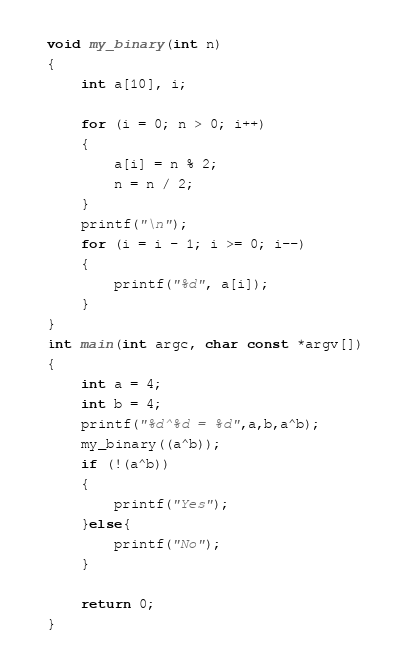Convert code to text. <code><loc_0><loc_0><loc_500><loc_500><_C_>void my_binary(int n)
{
    int a[10], i;

    for (i = 0; n > 0; i++)
    {
        a[i] = n % 2;
        n = n / 2;
    }
    printf("\n");
    for (i = i - 1; i >= 0; i--)
    {
        printf("%d", a[i]);
    }
}
int main(int argc, char const *argv[])
{    
    int a = 4;
    int b = 4;
    printf("%d^%d = %d",a,b,a^b);
    my_binary((a^b));
    if (!(a^b))
    {
        printf("Yes");
    }else{
        printf("No");
    }
    
    return 0;
}
</code> 